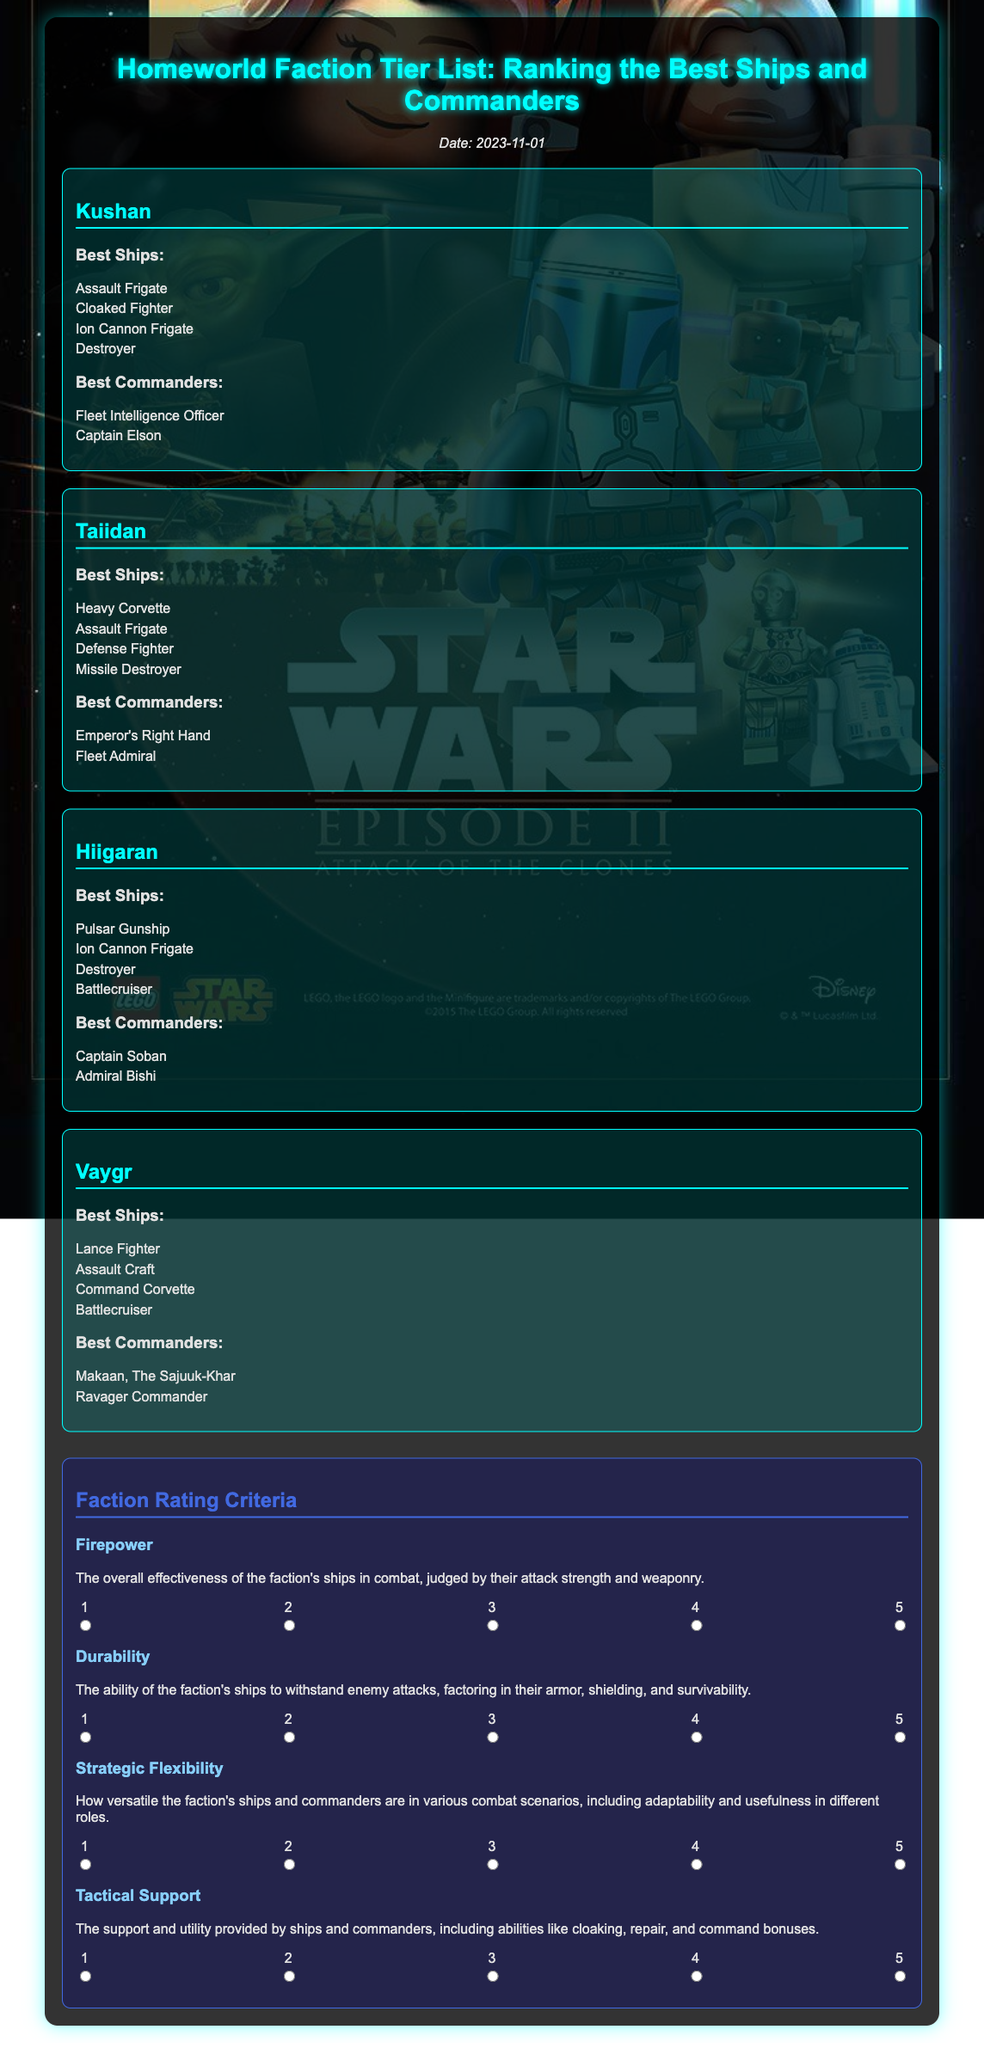What is the date of the voting document? The date provided in the document is indicated below the title, showing when the content was created.
Answer: 2023-11-01 Who is the Vaygr commander listed in the document? The document provides specific names for the best commanders in the Vaygr faction.
Answer: Makaan, The Sajuuk-Khar What is the first ship listed under Kushan? The best ships are listed under each faction, starting with the first mentioned ship for Kushan.
Answer: Assault Frigate What rating is given for Firepower? This aspect is rated on a scale from 1 to 5 and requires listeners to select a value in the voting section.
Answer: 1 to 5 Which faction's best ship is the Battlecruiser? The document categorizes the best ships for each faction, showing which factions have this ship listed.
Answer: Hiigaran and Vaygr How many criteria are mentioned for faction ratings? The document outlines specific criteria categories, providing a clear count of factors considered in rating.
Answer: Four What color is used in the title of the document? The color of the title is visually emphasized in the document, making it stand out against the background.
Answer: Cyan Which faction has the Heavy Corvette as one of its best ships? The best ships are detailed separately for each faction, identifying the one associated with the Heavy Corvette.
Answer: Taiidan 